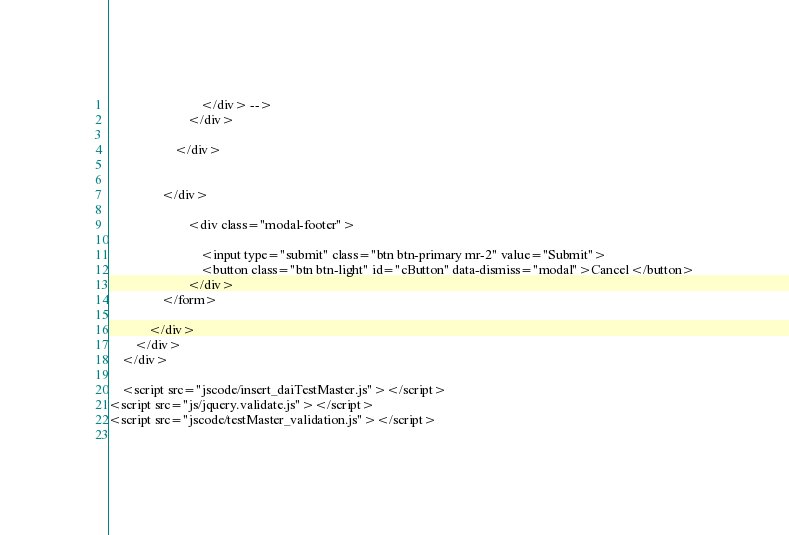<code> <loc_0><loc_0><loc_500><loc_500><_PHP_>                            </div> -->
                        </div>
                  
                    </div>

                   
                </div>

                        <div class="modal-footer">

                            <input type="submit" class="btn btn-primary mr-2" value="Submit">
                            <button class="btn btn-light" id="cButton" data-dismiss="modal">Cancel</button>
                        </div>
                </form>
              
            </div>
        </div>
    </div>

    <script src="jscode/insert_daiTestMaster.js"></script>
<script src="js/jquery.validate.js"></script>
<script src="jscode/testMaster_validation.js"></script>
  
</code> 